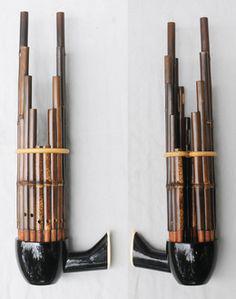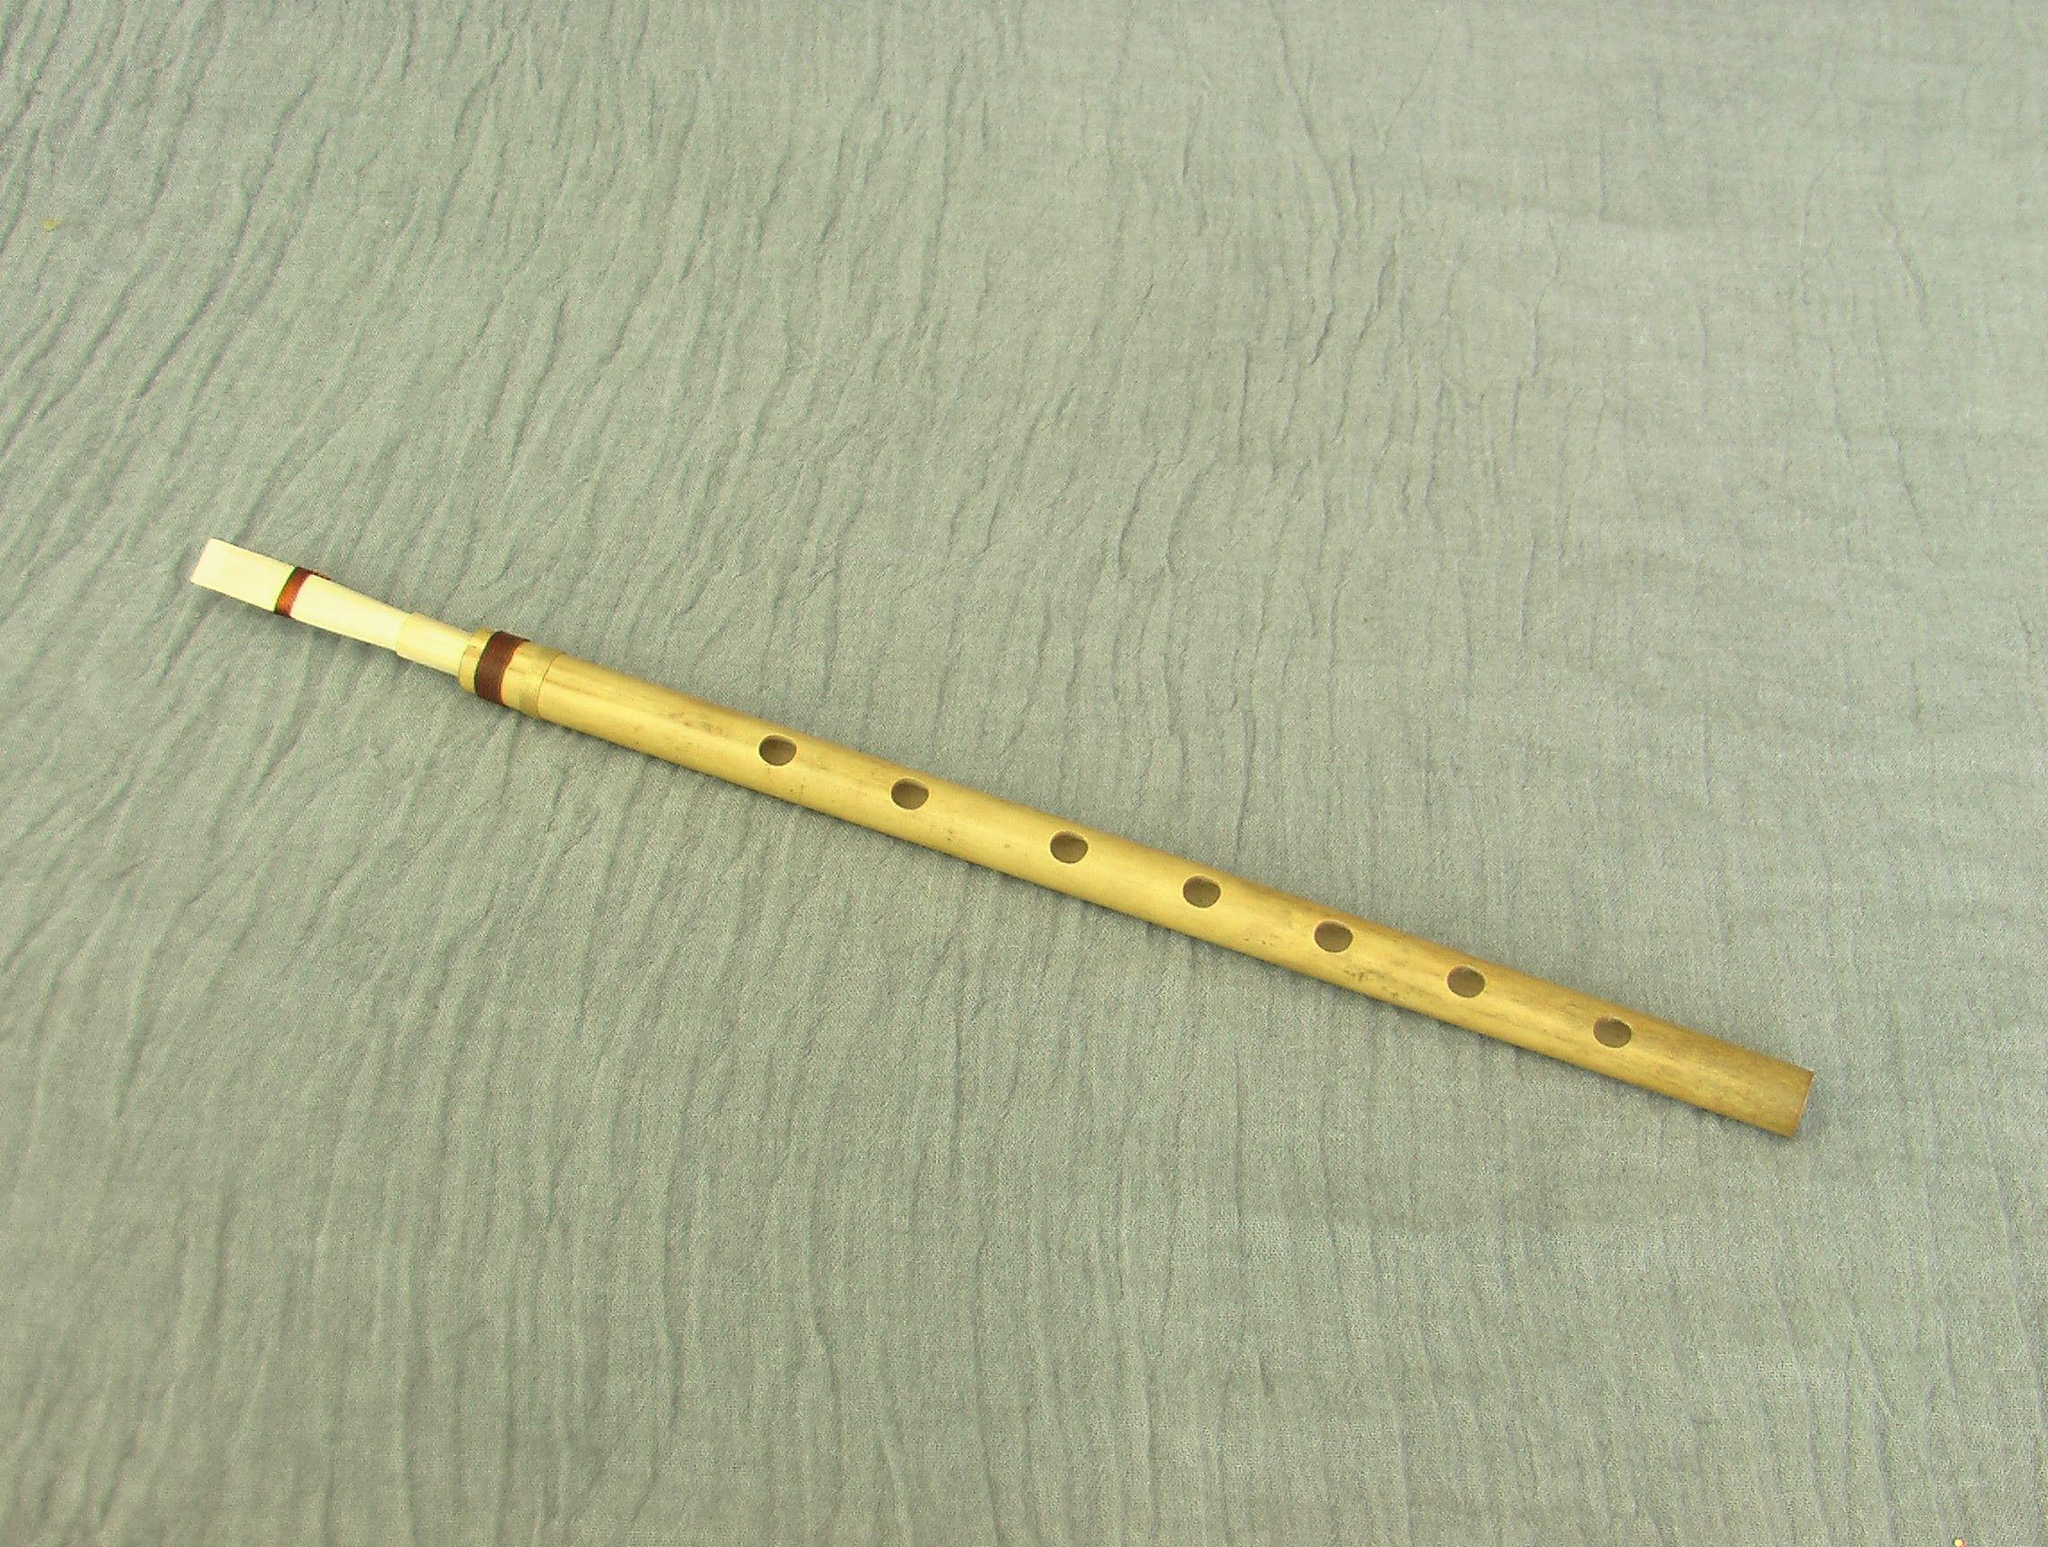The first image is the image on the left, the second image is the image on the right. Analyze the images presented: Is the assertion "Each image shows one bamboo flute displayed horizontally above a white card and beneath Asian characters superimposed over pink and blue color patches." valid? Answer yes or no. No. The first image is the image on the left, the second image is the image on the right. For the images shown, is this caption "Each of the instruments has an information card next to it." true? Answer yes or no. No. 